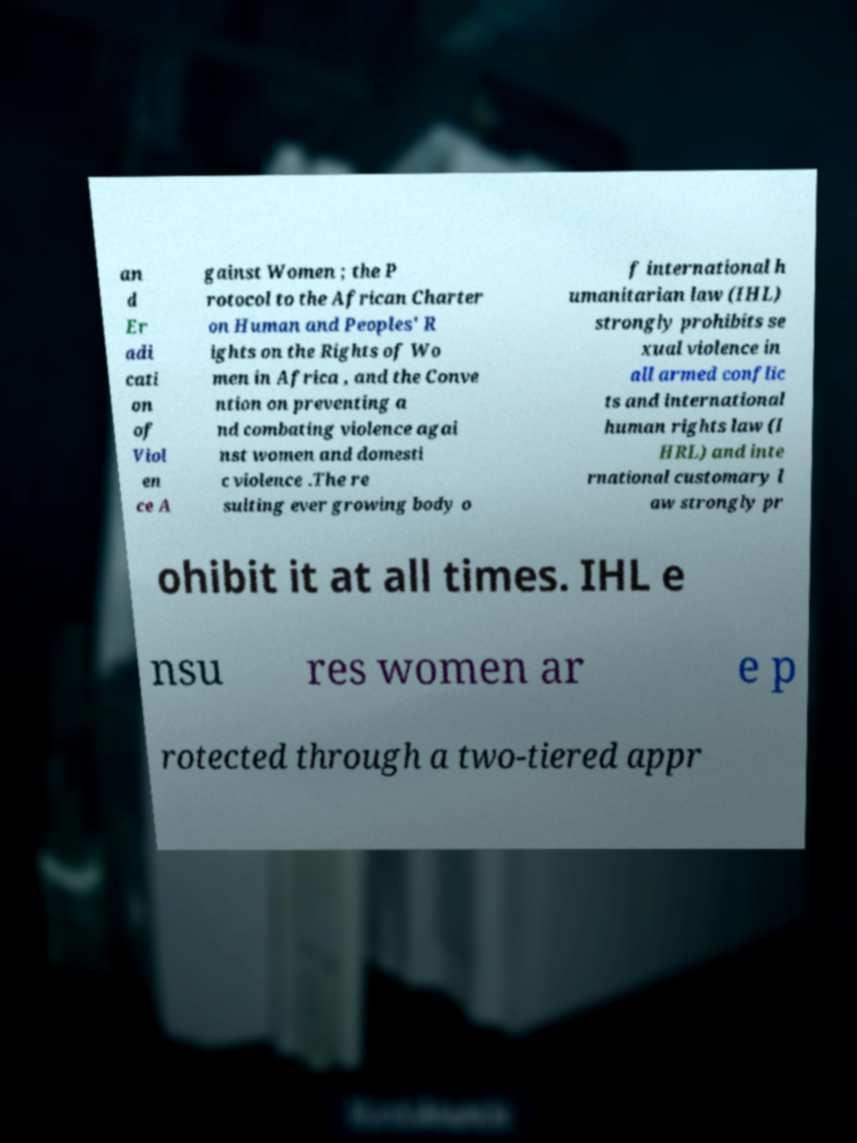There's text embedded in this image that I need extracted. Can you transcribe it verbatim? an d Er adi cati on of Viol en ce A gainst Women ; the P rotocol to the African Charter on Human and Peoples' R ights on the Rights of Wo men in Africa , and the Conve ntion on preventing a nd combating violence agai nst women and domesti c violence .The re sulting ever growing body o f international h umanitarian law (IHL) strongly prohibits se xual violence in all armed conflic ts and international human rights law (I HRL) and inte rnational customary l aw strongly pr ohibit it at all times. IHL e nsu res women ar e p rotected through a two-tiered appr 